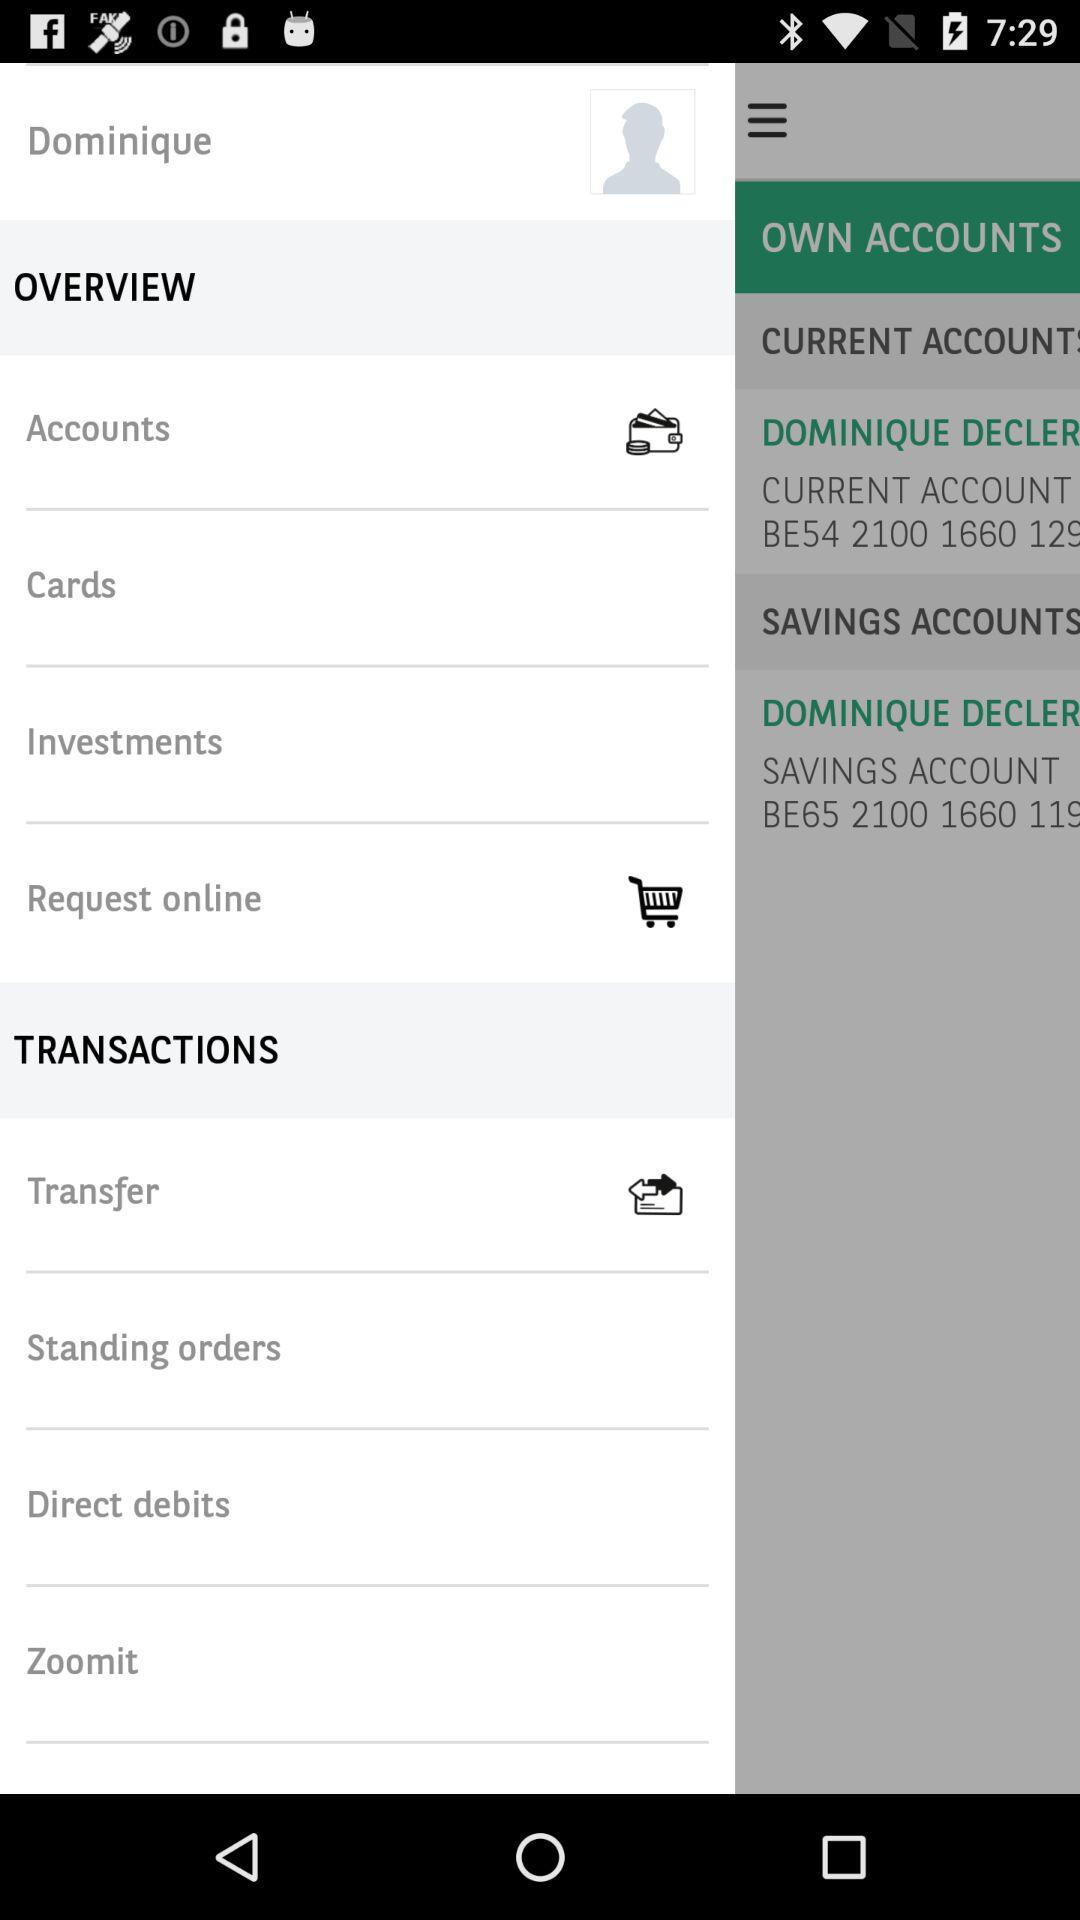What is the user name? The user name is Dominique. 